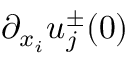Convert formula to latex. <formula><loc_0><loc_0><loc_500><loc_500>\partial _ { x _ { i } } u _ { j } ^ { \pm } ( 0 )</formula> 